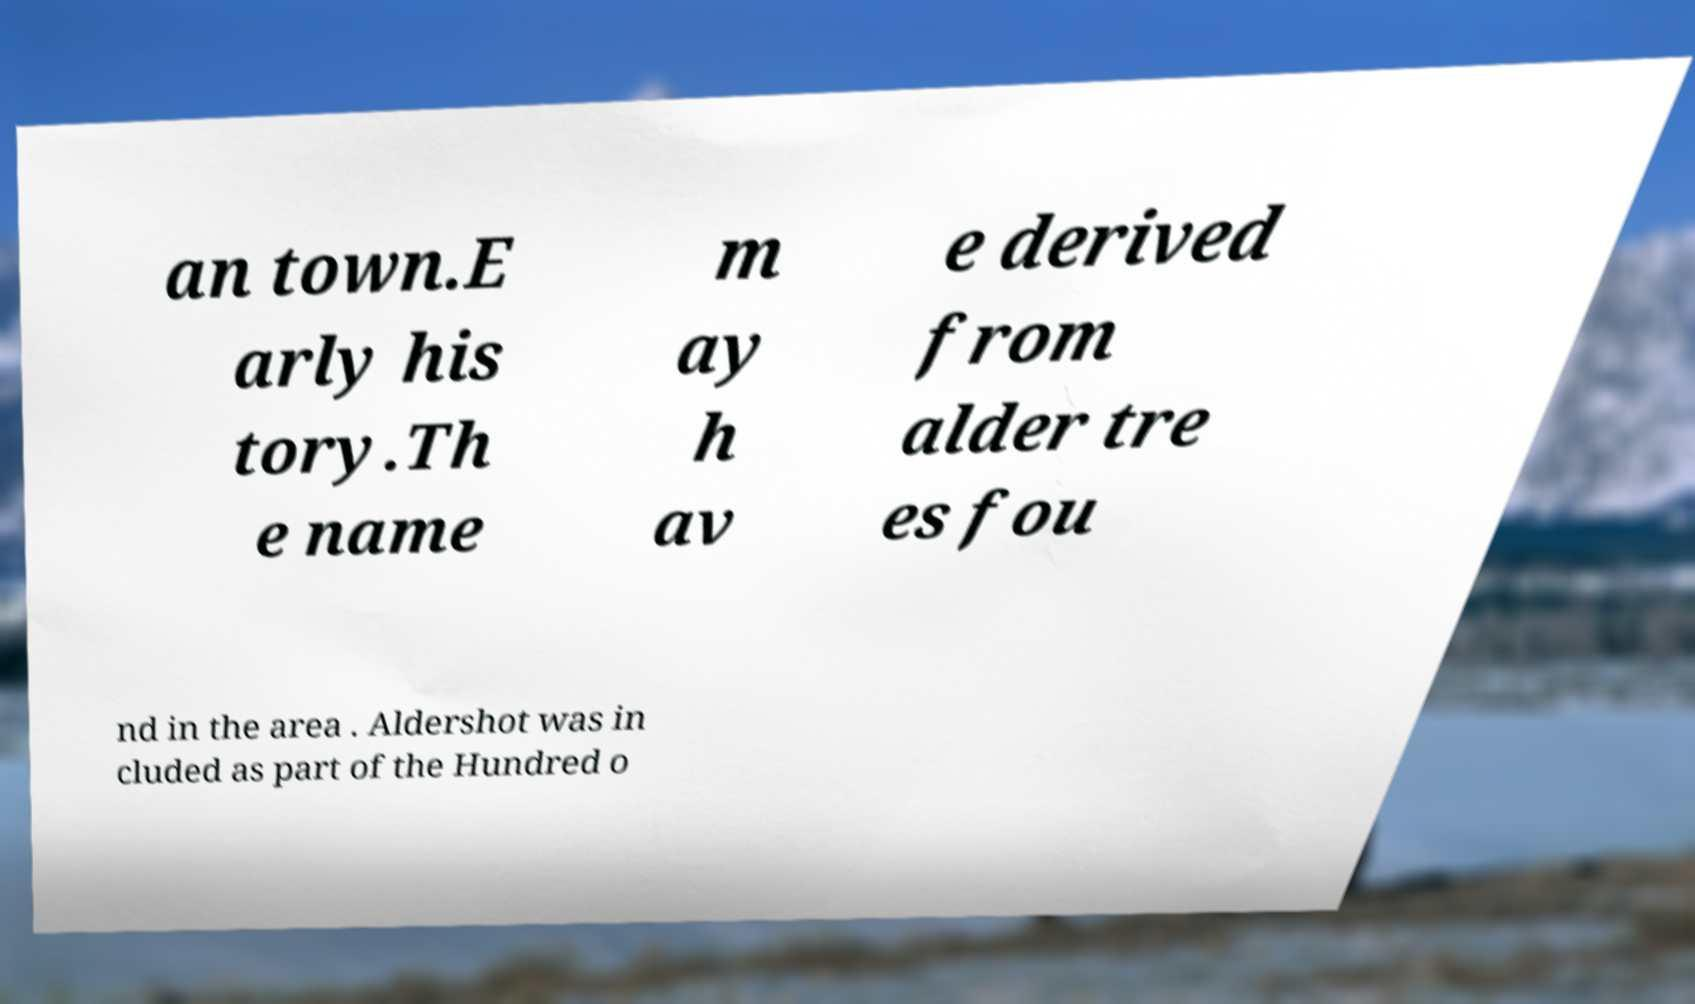I need the written content from this picture converted into text. Can you do that? an town.E arly his tory.Th e name m ay h av e derived from alder tre es fou nd in the area . Aldershot was in cluded as part of the Hundred o 